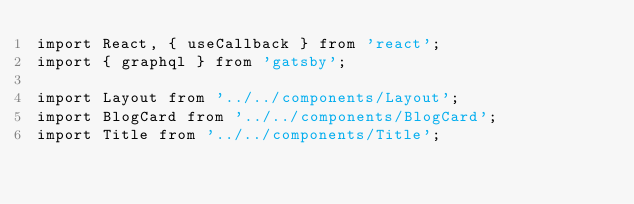<code> <loc_0><loc_0><loc_500><loc_500><_JavaScript_>import React, { useCallback } from 'react';
import { graphql } from 'gatsby';

import Layout from '../../components/Layout';
import BlogCard from '../../components/BlogCard';
import Title from '../../components/Title';</code> 